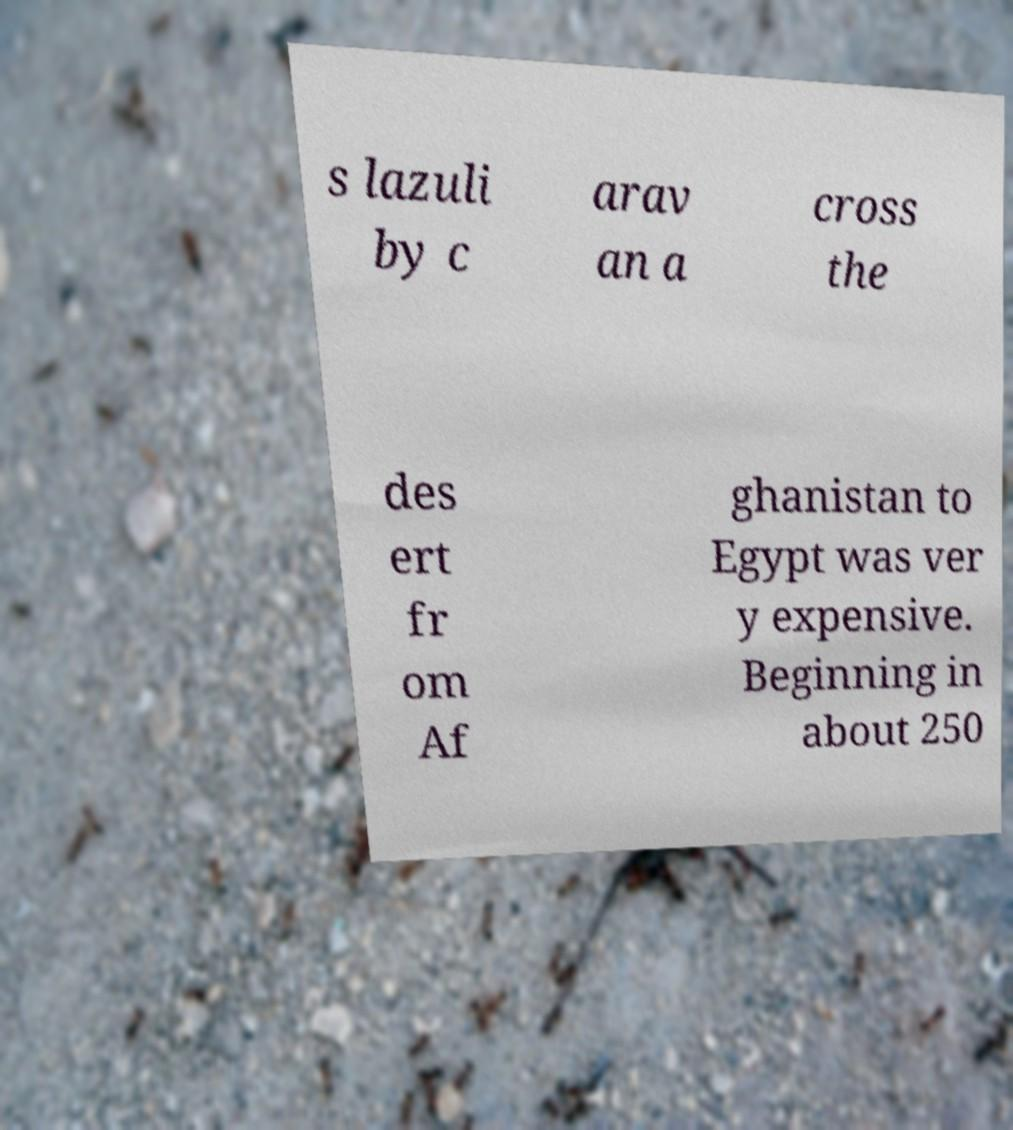There's text embedded in this image that I need extracted. Can you transcribe it verbatim? s lazuli by c arav an a cross the des ert fr om Af ghanistan to Egypt was ver y expensive. Beginning in about 250 